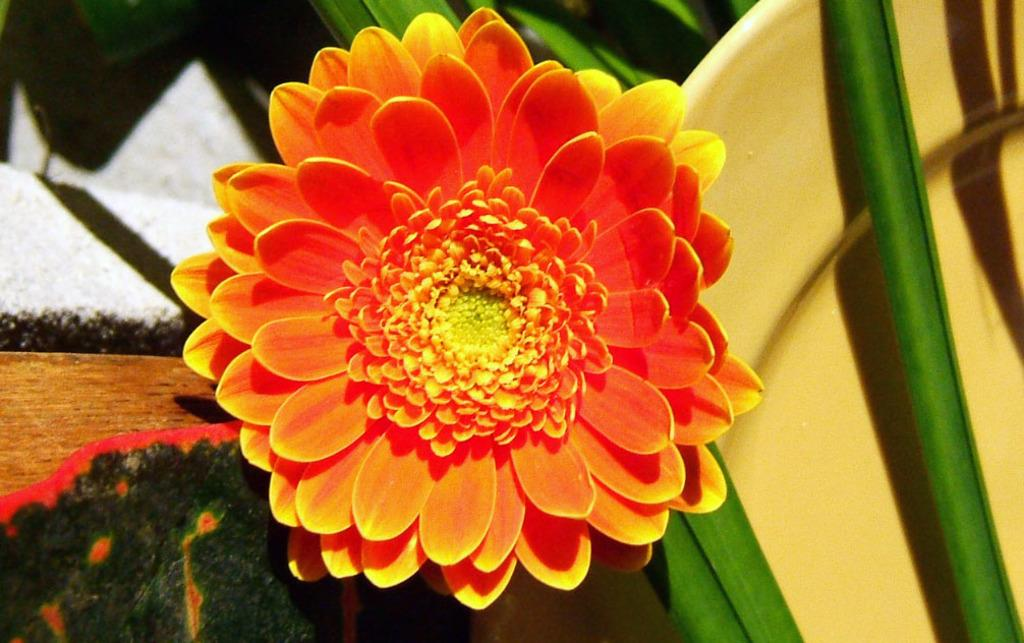What type of plant can be seen in the image? There is a flower in the image. What else is visible in the image besides the flower? There are leaves in the image. What type of pocket can be seen in the image? There is no pocket present in the image. What musical instrument is being played in the image? There is no musical instrument or indication of music in the image. 